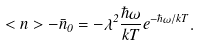<formula> <loc_0><loc_0><loc_500><loc_500>< n > - \bar { n } _ { 0 } = - \lambda ^ { 2 } \frac { \hbar { \omega } } { k T } e ^ { - \hbar { \omega } / k T } .</formula> 